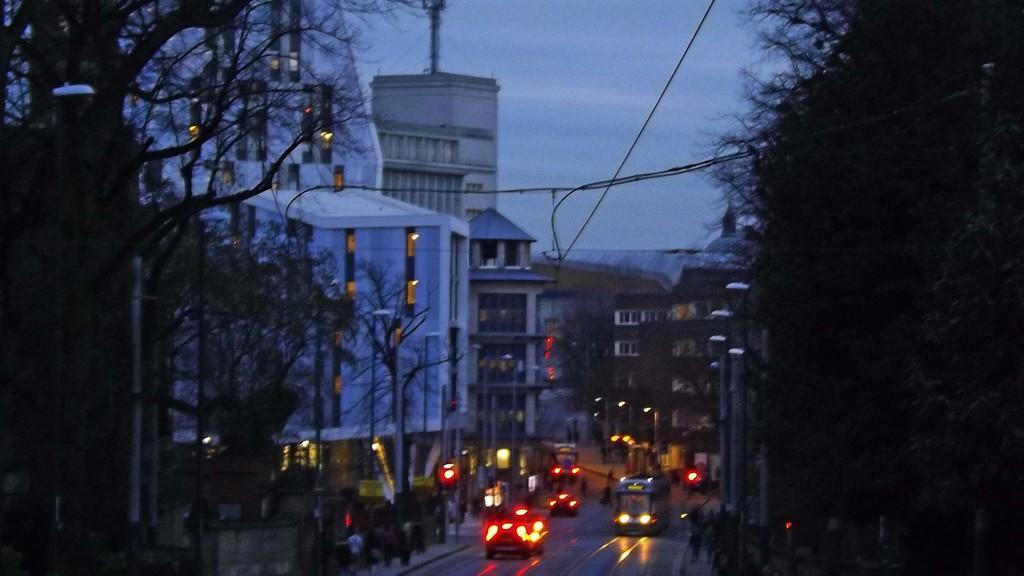In one or two sentences, can you explain what this image depicts? Here there are buildings with the windows, here there are vehicles on the road, here there are trees, this is sky. 